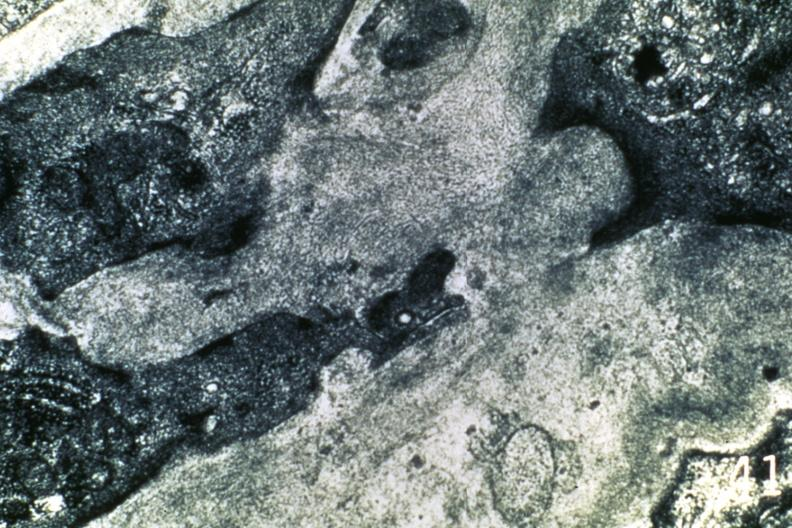s cachexia present?
Answer the question using a single word or phrase. No 